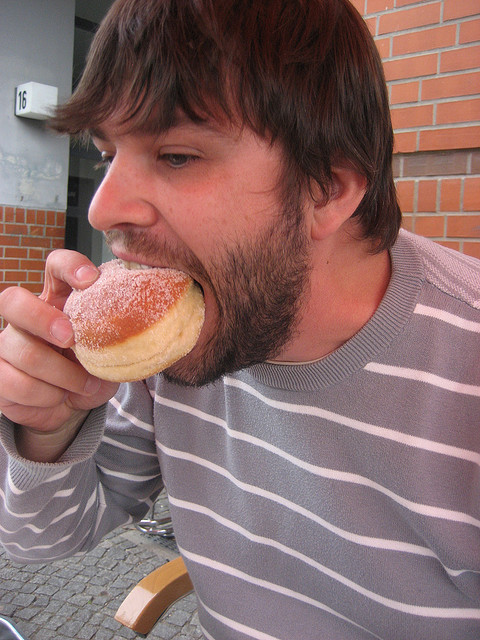Identify and read out the text in this image. 16 